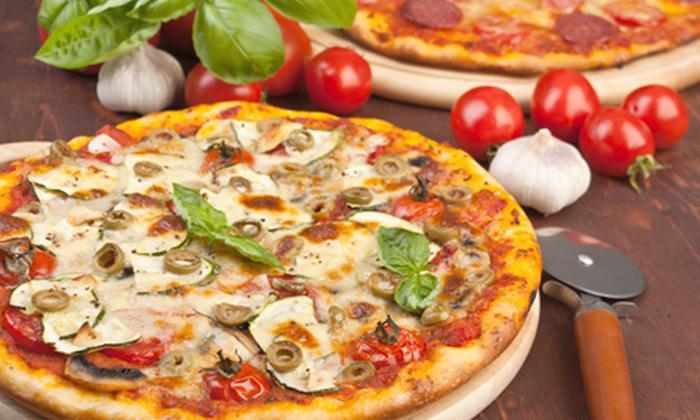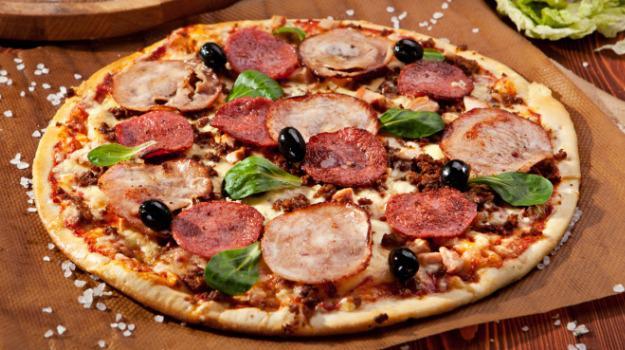The first image is the image on the left, the second image is the image on the right. Considering the images on both sides, is "One of the pizzas has a single slice lifted with cheese stretching from it, and the other pizza is sliced but has all slices in place." valid? Answer yes or no. No. The first image is the image on the left, the second image is the image on the right. For the images shown, is this caption "there is a pizza with a slice being lifted with green peppers on it" true? Answer yes or no. No. 